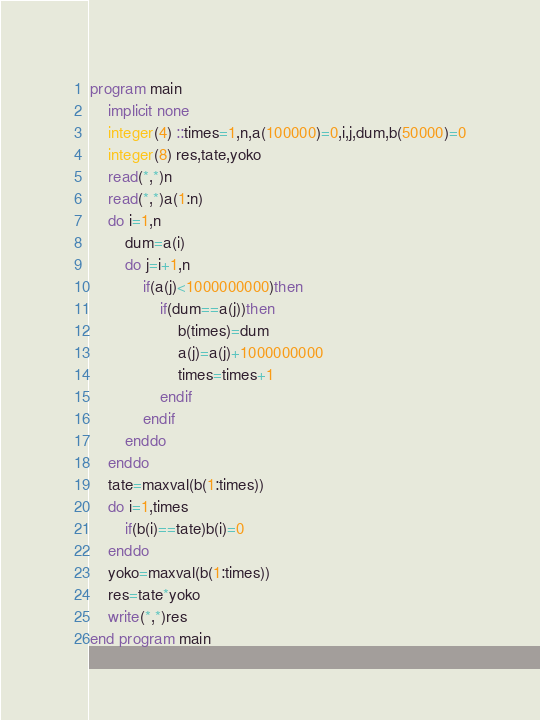<code> <loc_0><loc_0><loc_500><loc_500><_FORTRAN_>program main
	implicit none
	integer(4) ::times=1,n,a(100000)=0,i,j,dum,b(50000)=0
	integer(8) res,tate,yoko
	read(*,*)n
	read(*,*)a(1:n)
	do i=1,n
		dum=a(i)
		do j=i+1,n
			if(a(j)<1000000000)then
				if(dum==a(j))then
					b(times)=dum
					a(j)=a(j)+1000000000
					times=times+1
				endif
			endif
		enddo
	enddo
	tate=maxval(b(1:times))
	do i=1,times
		if(b(i)==tate)b(i)=0
	enddo
	yoko=maxval(b(1:times))
	res=tate*yoko
	write(*,*)res
end program main
</code> 